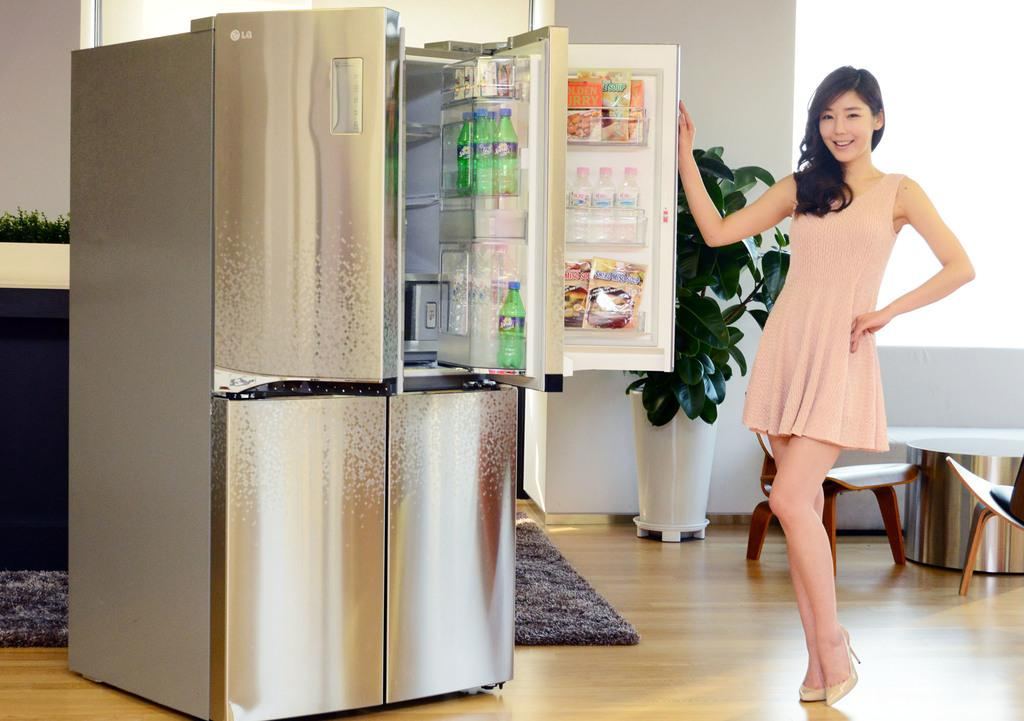<image>
Describe the image concisely. A lady stands beside an impressive double LG fridge freezer. 